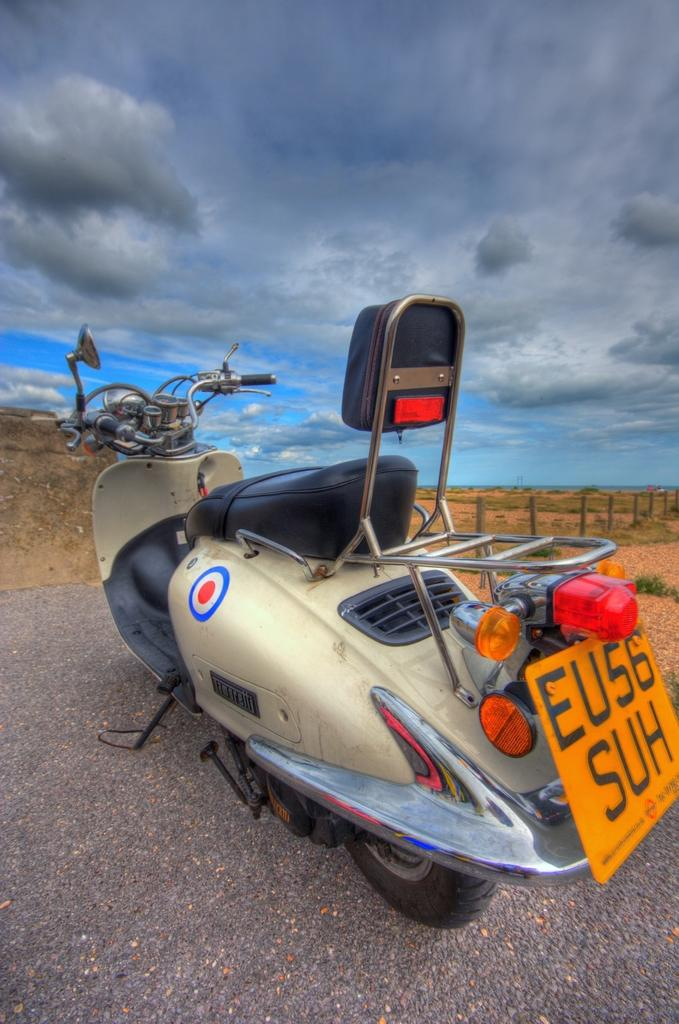What is the main subject in the center of the image? There is a motorbike in the center of the image. What is located at the bottom of the image? There is a road at the bottom of the image. What can be seen in the background of the image? The sky and a fence are visible in the background of the image. Can you hear the value of the motorbike in the image? The value of the motorbike cannot be heard, as it is not an audible element in the image. 